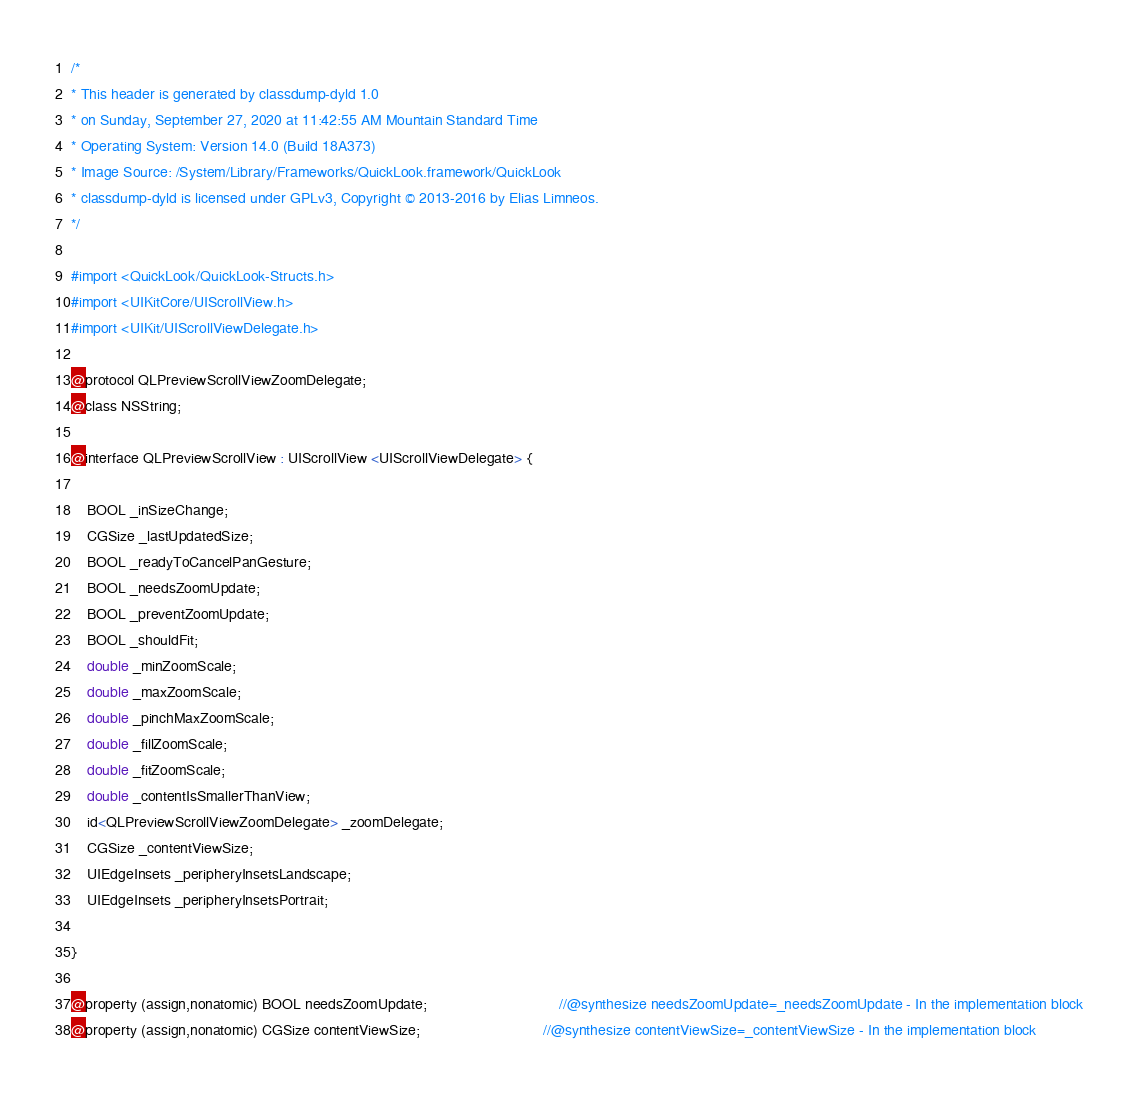<code> <loc_0><loc_0><loc_500><loc_500><_C_>/*
* This header is generated by classdump-dyld 1.0
* on Sunday, September 27, 2020 at 11:42:55 AM Mountain Standard Time
* Operating System: Version 14.0 (Build 18A373)
* Image Source: /System/Library/Frameworks/QuickLook.framework/QuickLook
* classdump-dyld is licensed under GPLv3, Copyright © 2013-2016 by Elias Limneos.
*/

#import <QuickLook/QuickLook-Structs.h>
#import <UIKitCore/UIScrollView.h>
#import <UIKit/UIScrollViewDelegate.h>

@protocol QLPreviewScrollViewZoomDelegate;
@class NSString;

@interface QLPreviewScrollView : UIScrollView <UIScrollViewDelegate> {

	BOOL _inSizeChange;
	CGSize _lastUpdatedSize;
	BOOL _readyToCancelPanGesture;
	BOOL _needsZoomUpdate;
	BOOL _preventZoomUpdate;
	BOOL _shouldFit;
	double _minZoomScale;
	double _maxZoomScale;
	double _pinchMaxZoomScale;
	double _fillZoomScale;
	double _fitZoomScale;
	double _contentIsSmallerThanView;
	id<QLPreviewScrollViewZoomDelegate> _zoomDelegate;
	CGSize _contentViewSize;
	UIEdgeInsets _peripheryInsetsLandscape;
	UIEdgeInsets _peripheryInsetsPortrait;

}

@property (assign,nonatomic) BOOL needsZoomUpdate;                                //@synthesize needsZoomUpdate=_needsZoomUpdate - In the implementation block
@property (assign,nonatomic) CGSize contentViewSize;                              //@synthesize contentViewSize=_contentViewSize - In the implementation block</code> 